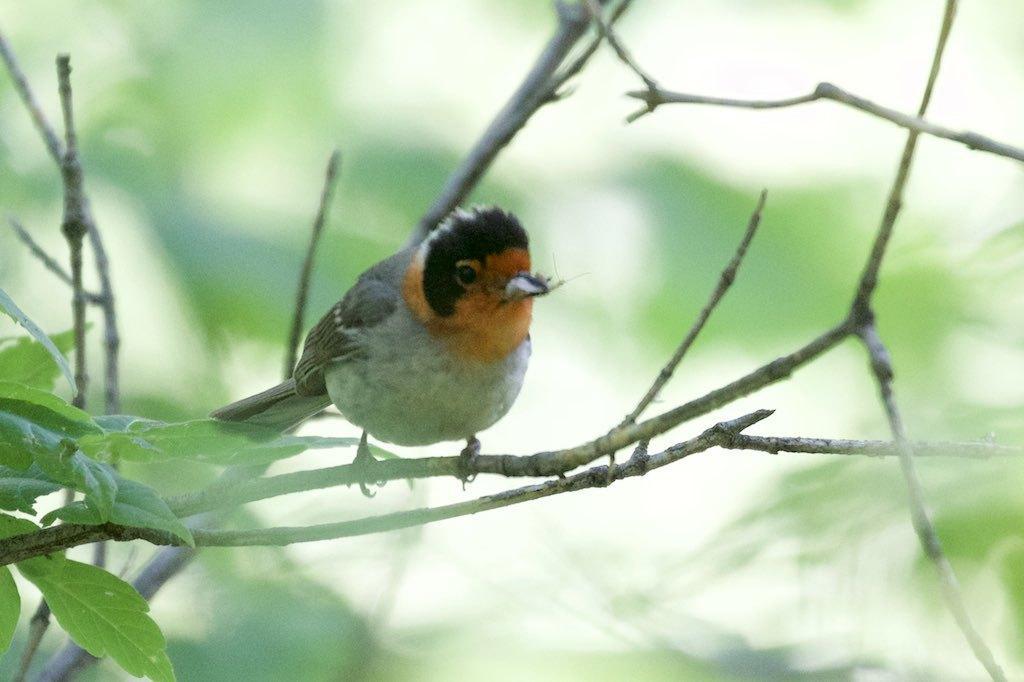Can you describe this image briefly? In this image there is a bird on the stem. Left side there are leaves and stems. Background is blurry. 